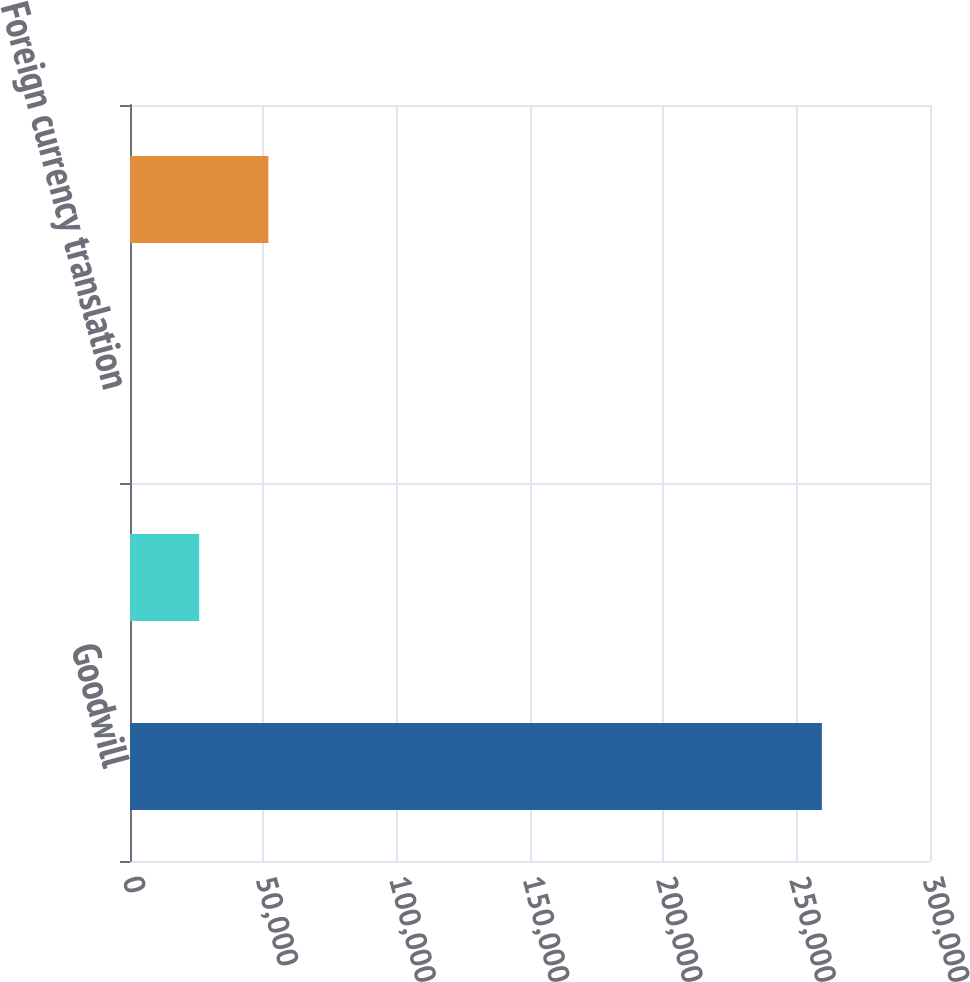Convert chart to OTSL. <chart><loc_0><loc_0><loc_500><loc_500><bar_chart><fcel>Goodwill<fcel>Accumulated impairment losses<fcel>Foreign currency translation<fcel>Acquisitions<nl><fcel>259452<fcel>25948.1<fcel>3.22<fcel>51893<nl></chart> 